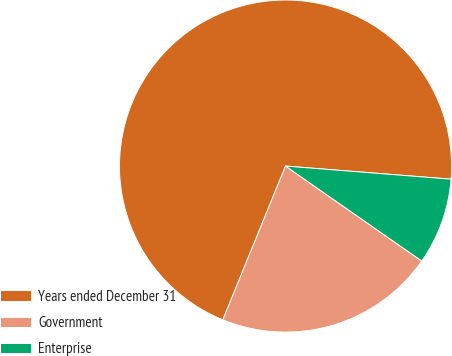<chart> <loc_0><loc_0><loc_500><loc_500><pie_chart><fcel>Years ended December 31<fcel>Government<fcel>Enterprise<nl><fcel>70.09%<fcel>21.47%<fcel>8.43%<nl></chart> 